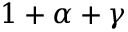<formula> <loc_0><loc_0><loc_500><loc_500>1 + \alpha + \gamma</formula> 